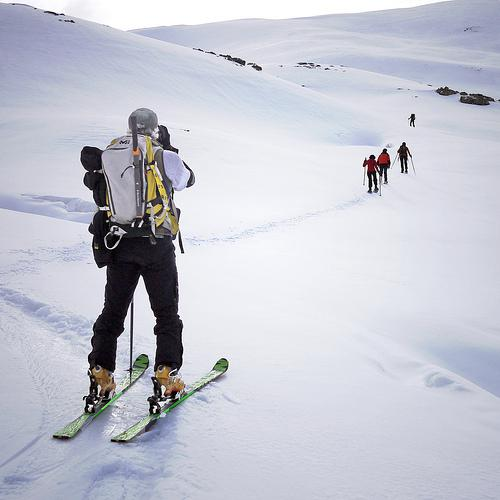Question: how is the pond scummy?
Choices:
A. Trash.
B. Pollution.
C. Needs cleaning.
D. No pond.
Answer with the letter. Answer: D Question: where is the horse?
Choices:
A. In barn.
B. In pen.
C. In pasture.
D. No horse.
Answer with the letter. Answer: D Question: when are they on skis?
Choices:
A. When skiing.
B. Now.
C. When testing them.
D. When skiing cross country.
Answer with the letter. Answer: B Question: what are they doing?
Choices:
A. Playing.
B. Talking.
C. Skiing.
D. Exercising.
Answer with the letter. Answer: C Question: what is on their feet?
Choices:
A. Boots.
B. Skis.
C. Shoes.
D. Socks.
Answer with the letter. Answer: B 